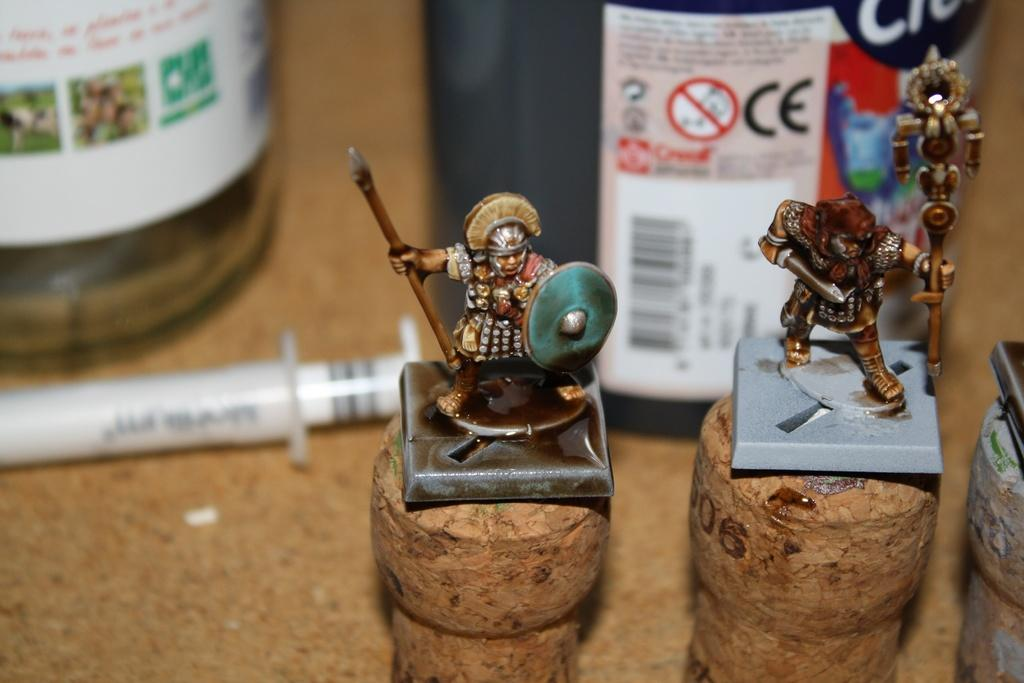What objects can be seen in the foreground of the image? There are two toys in the foreground of the image. What are the toys holding in their hands? The toys are holding a shield and an arrow. What can be seen in the background of the image? In the background, there are two bottles on the ground and a syringe on the ground. What type of wrench is being used to fix the carriage in the image? There is no wrench or carriage present in the image. What is the color of the neck of the person holding the shield in the image? There are no people present in the image, only toys. 